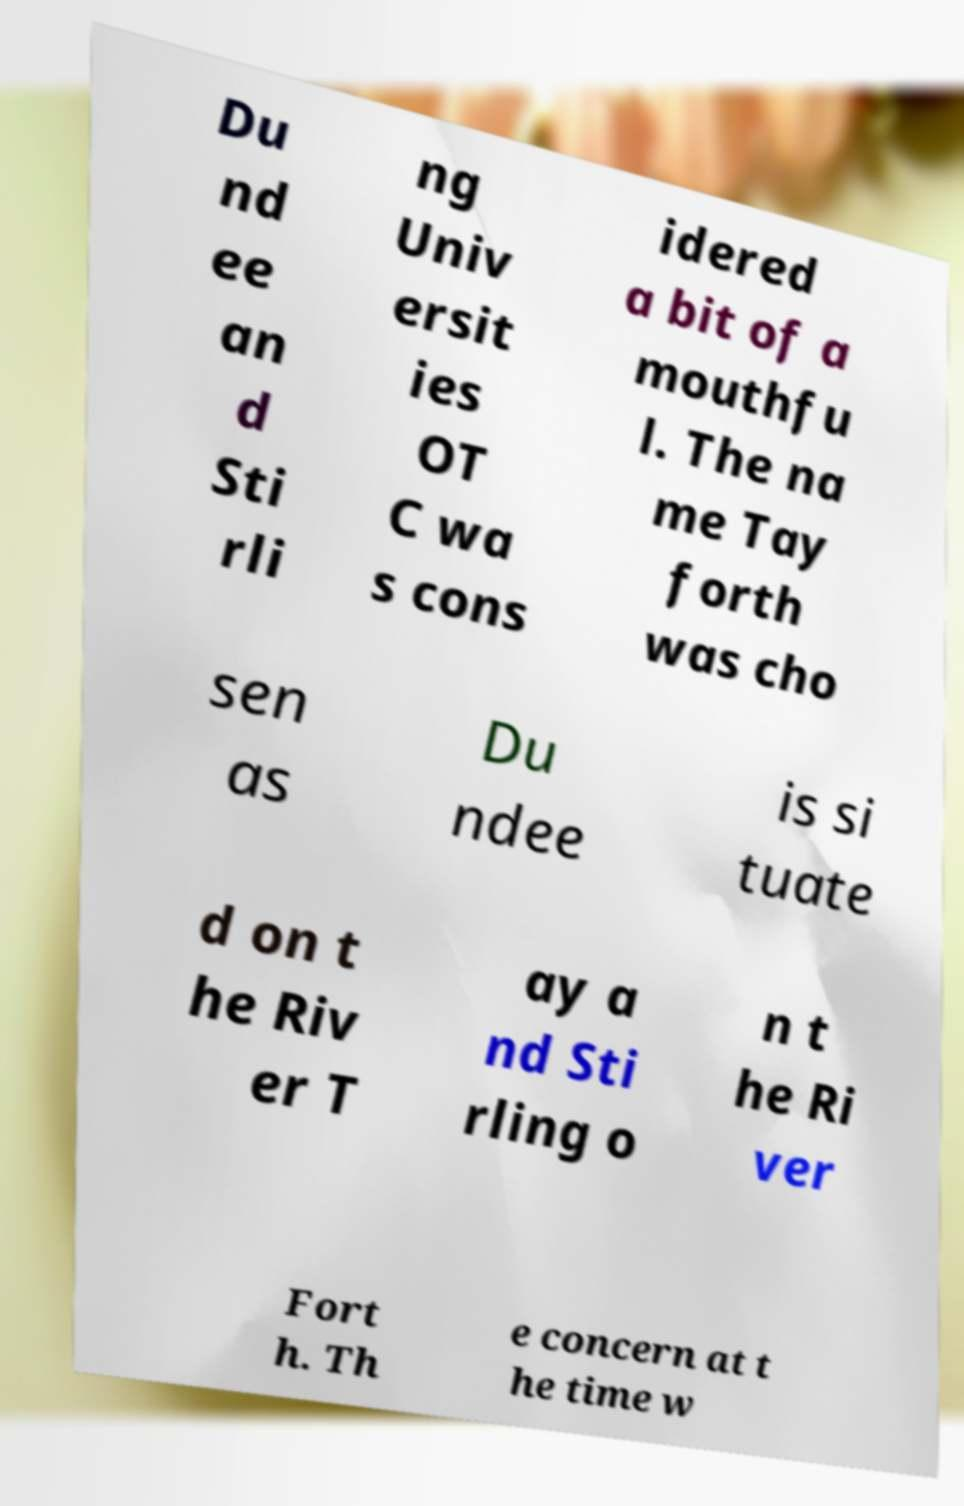Can you read and provide the text displayed in the image?This photo seems to have some interesting text. Can you extract and type it out for me? Du nd ee an d Sti rli ng Univ ersit ies OT C wa s cons idered a bit of a mouthfu l. The na me Tay forth was cho sen as Du ndee is si tuate d on t he Riv er T ay a nd Sti rling o n t he Ri ver Fort h. Th e concern at t he time w 